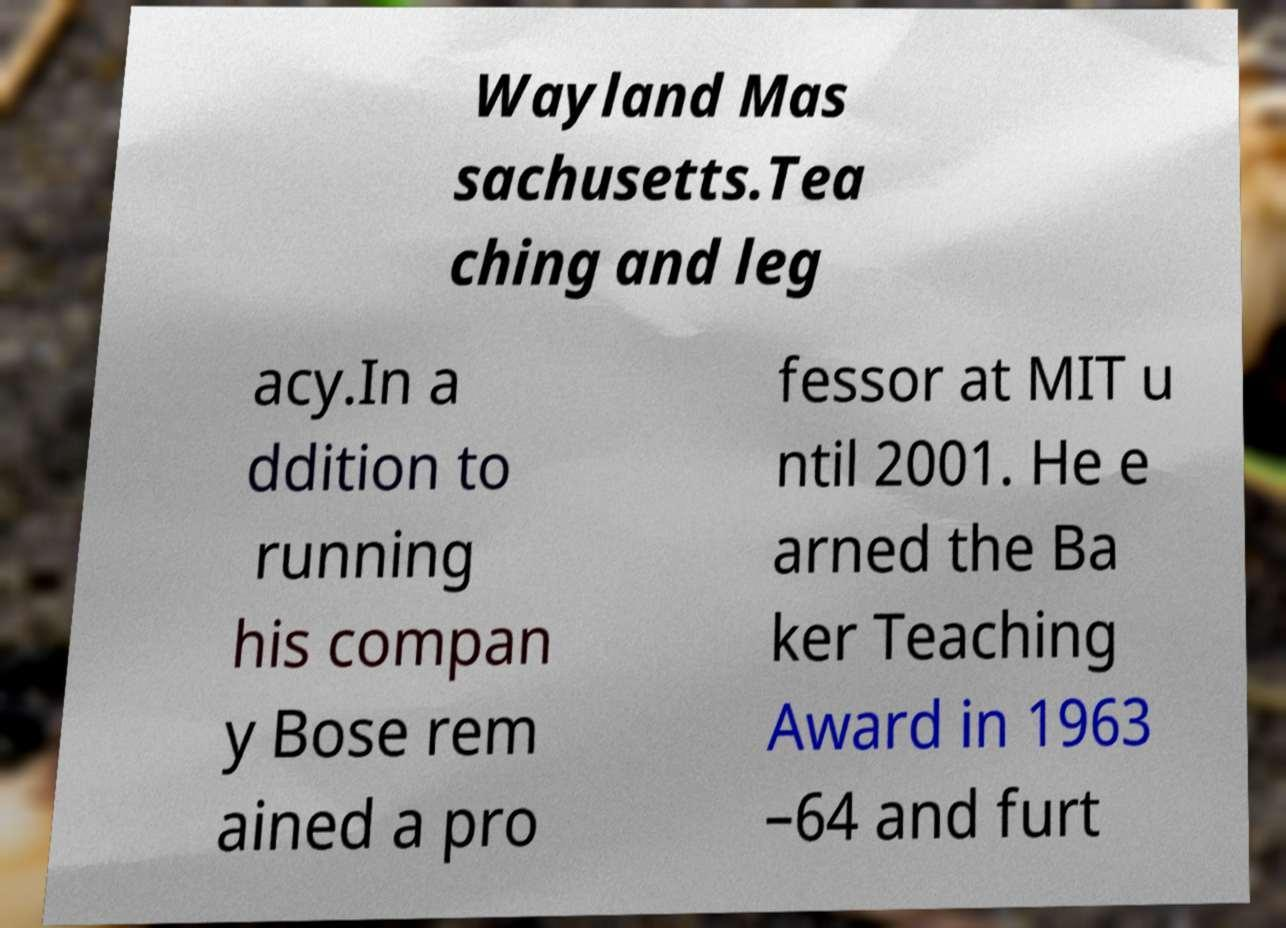Can you read and provide the text displayed in the image?This photo seems to have some interesting text. Can you extract and type it out for me? Wayland Mas sachusetts.Tea ching and leg acy.In a ddition to running his compan y Bose rem ained a pro fessor at MIT u ntil 2001. He e arned the Ba ker Teaching Award in 1963 –64 and furt 